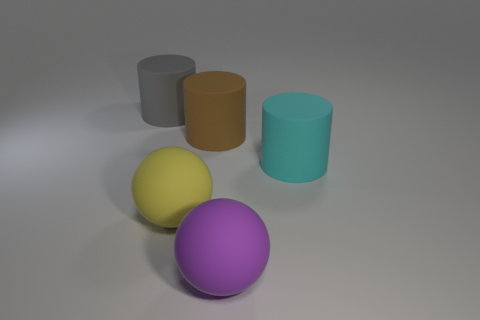What is the ball that is to the right of the large matte sphere that is left of the large matte sphere that is to the right of the large yellow ball made of? The ball in question appears to be a large purple sphere. While the image does not provide enough information to definitively determine the material composition, it visually resembles the textural qualities of a matte plastic finish. 